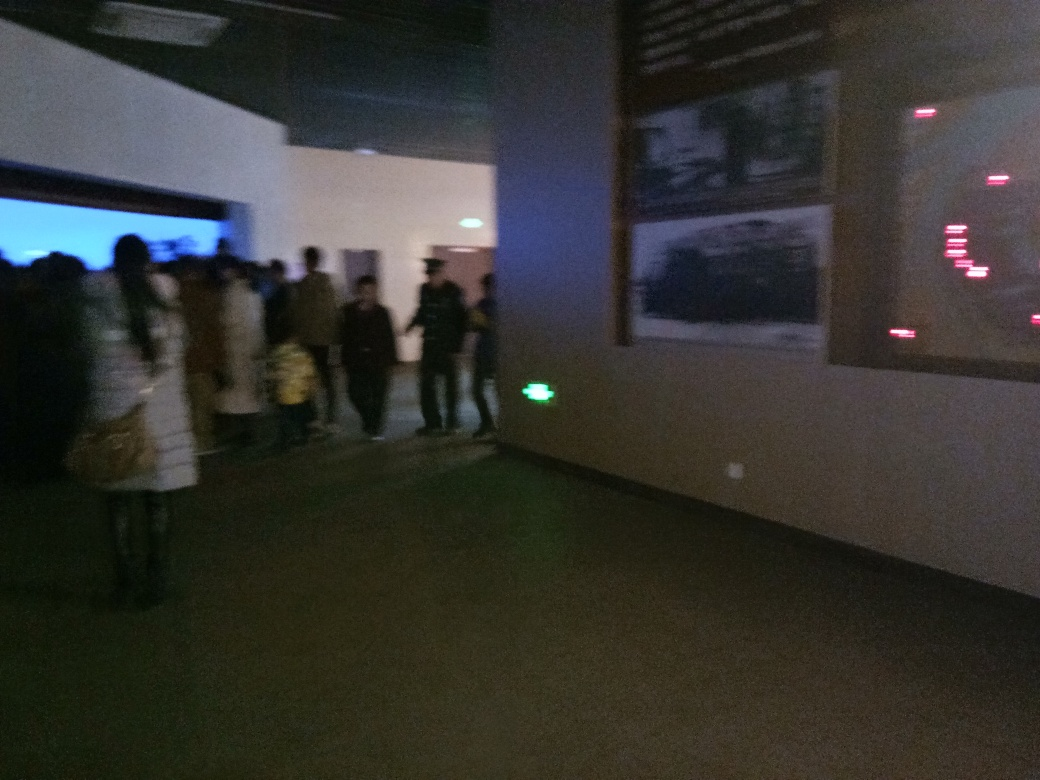What is the atmosphere of the place shown in the image? The atmosphere appears to be subdued and calm, featuring soft lighting and a crowd of people engaging in what looks like quiet conversation or contemplation, which is typical of an art exhibit or a museum setting. 